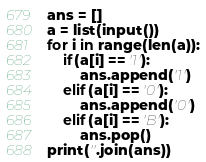<code> <loc_0><loc_0><loc_500><loc_500><_Python_>ans = []
a = list(input())
for i in range(len(a)):
	if(a[i] == '1'):
		ans.append('1')
	elif(a[i] == '0'):
		ans.append('0')
	elif(a[i] == 'B'):
		ans.pop()
print(''.join(ans))</code> 